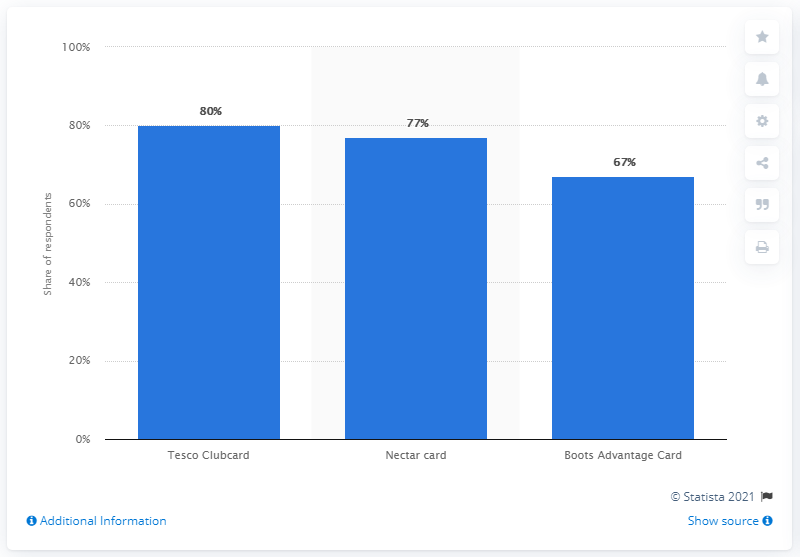Specify some key components in this picture. Tesco Clubcard is the most popular loyalty card scheme in the United Kingdom. 